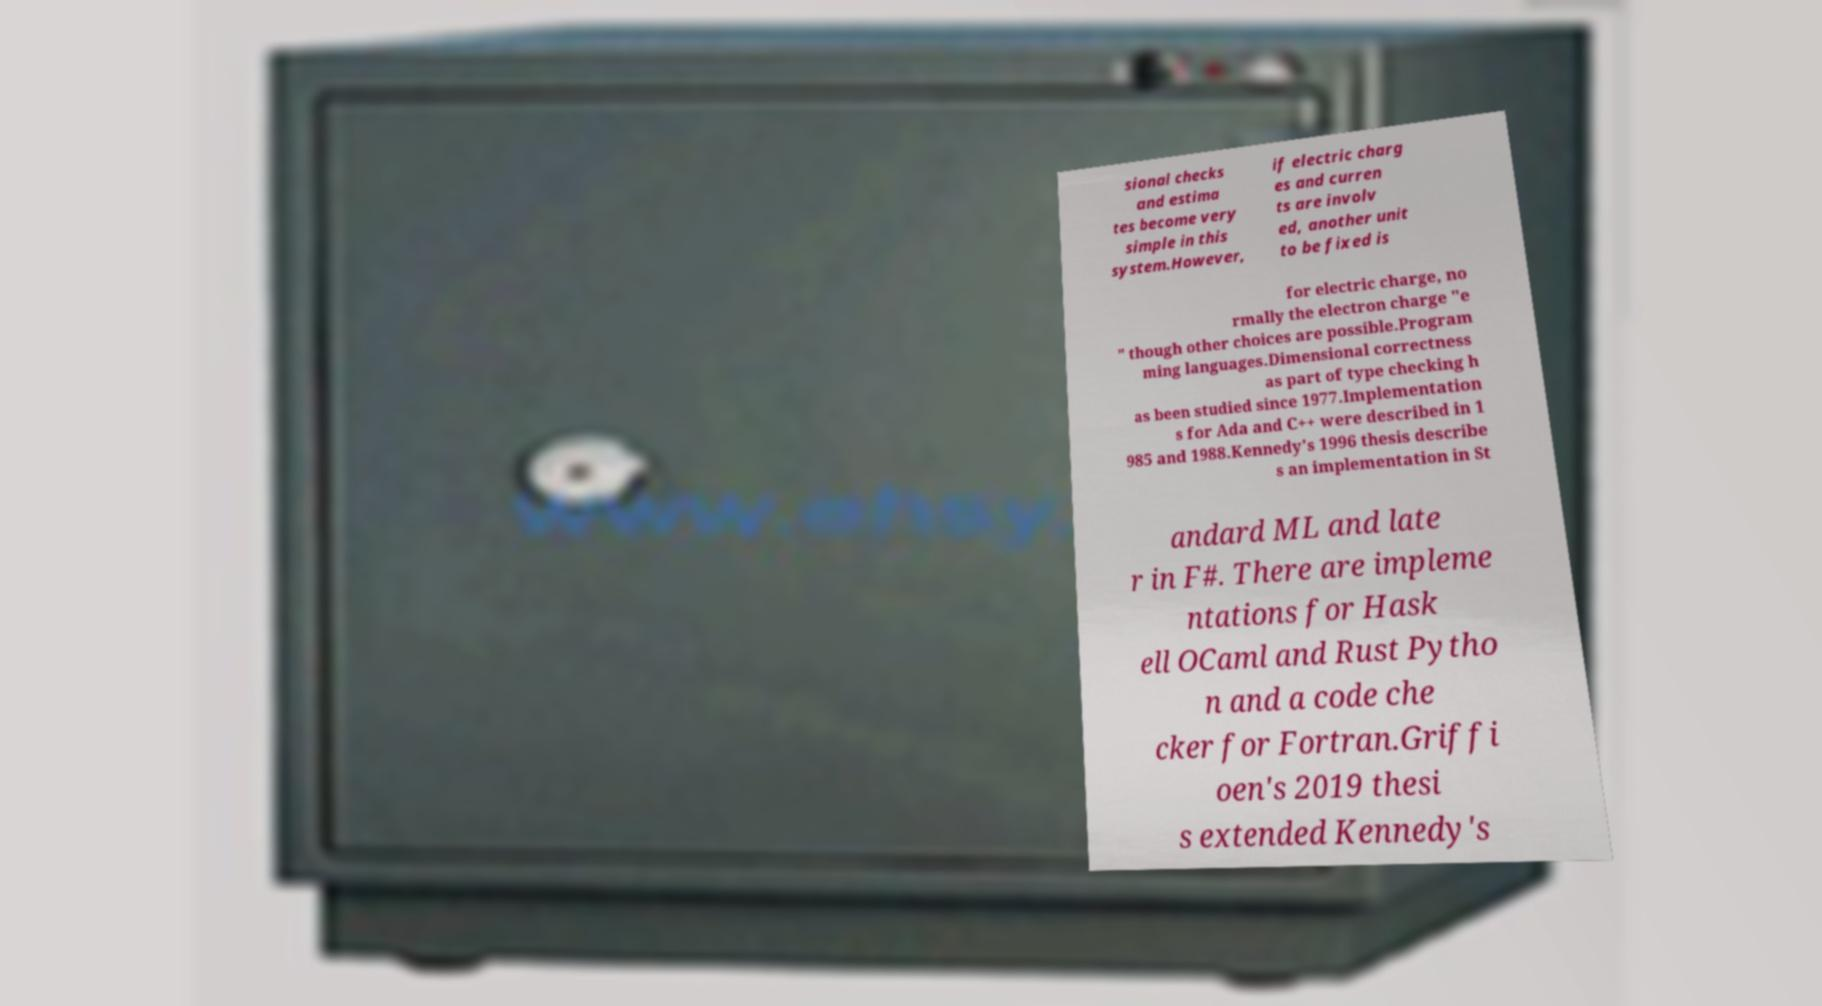Can you accurately transcribe the text from the provided image for me? sional checks and estima tes become very simple in this system.However, if electric charg es and curren ts are involv ed, another unit to be fixed is for electric charge, no rmally the electron charge "e " though other choices are possible.Program ming languages.Dimensional correctness as part of type checking h as been studied since 1977.Implementation s for Ada and C++ were described in 1 985 and 1988.Kennedy's 1996 thesis describe s an implementation in St andard ML and late r in F#. There are impleme ntations for Hask ell OCaml and Rust Pytho n and a code che cker for Fortran.Griffi oen's 2019 thesi s extended Kennedy's 